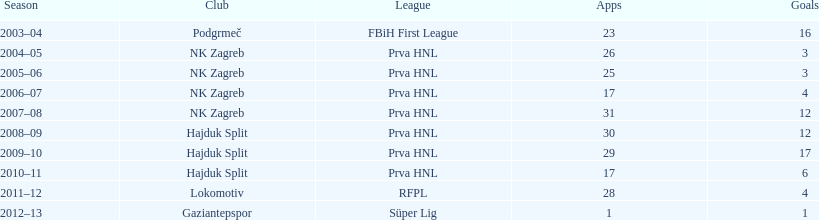At most 26 apps, how many goals were scored in 2004-2005 3. I'm looking to parse the entire table for insights. Could you assist me with that? {'header': ['Season', 'Club', 'League', 'Apps', 'Goals'], 'rows': [['2003–04', 'Podgrmeč', 'FBiH First League', '23', '16'], ['2004–05', 'NK Zagreb', 'Prva HNL', '26', '3'], ['2005–06', 'NK Zagreb', 'Prva HNL', '25', '3'], ['2006–07', 'NK Zagreb', 'Prva HNL', '17', '4'], ['2007–08', 'NK Zagreb', 'Prva HNL', '31', '12'], ['2008–09', 'Hajduk Split', 'Prva HNL', '30', '12'], ['2009–10', 'Hajduk Split', 'Prva HNL', '29', '17'], ['2010–11', 'Hajduk Split', 'Prva HNL', '17', '6'], ['2011–12', 'Lokomotiv', 'RFPL', '28', '4'], ['2012–13', 'Gaziantepspor', 'Süper Lig', '1', '1']]} 